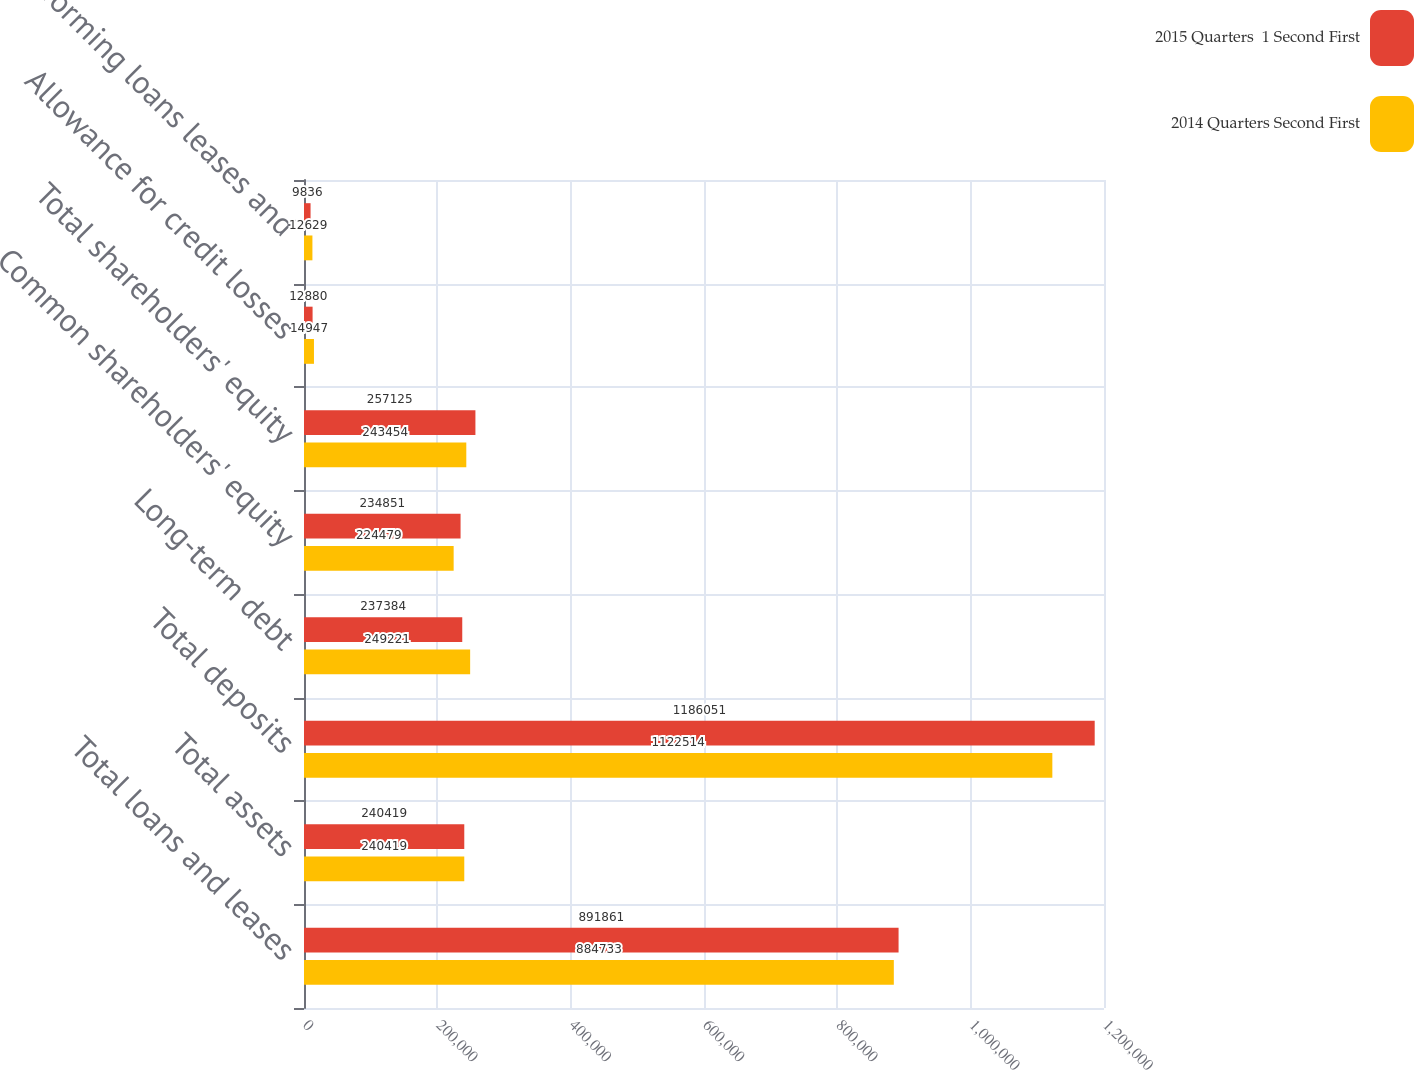<chart> <loc_0><loc_0><loc_500><loc_500><stacked_bar_chart><ecel><fcel>Total loans and leases<fcel>Total assets<fcel>Total deposits<fcel>Long-term debt<fcel>Common shareholders' equity<fcel>Total shareholders' equity<fcel>Allowance for credit losses<fcel>Nonperforming loans leases and<nl><fcel>2015 Quarters  1 Second First<fcel>891861<fcel>240419<fcel>1.18605e+06<fcel>237384<fcel>234851<fcel>257125<fcel>12880<fcel>9836<nl><fcel>2014 Quarters Second First<fcel>884733<fcel>240419<fcel>1.12251e+06<fcel>249221<fcel>224479<fcel>243454<fcel>14947<fcel>12629<nl></chart> 